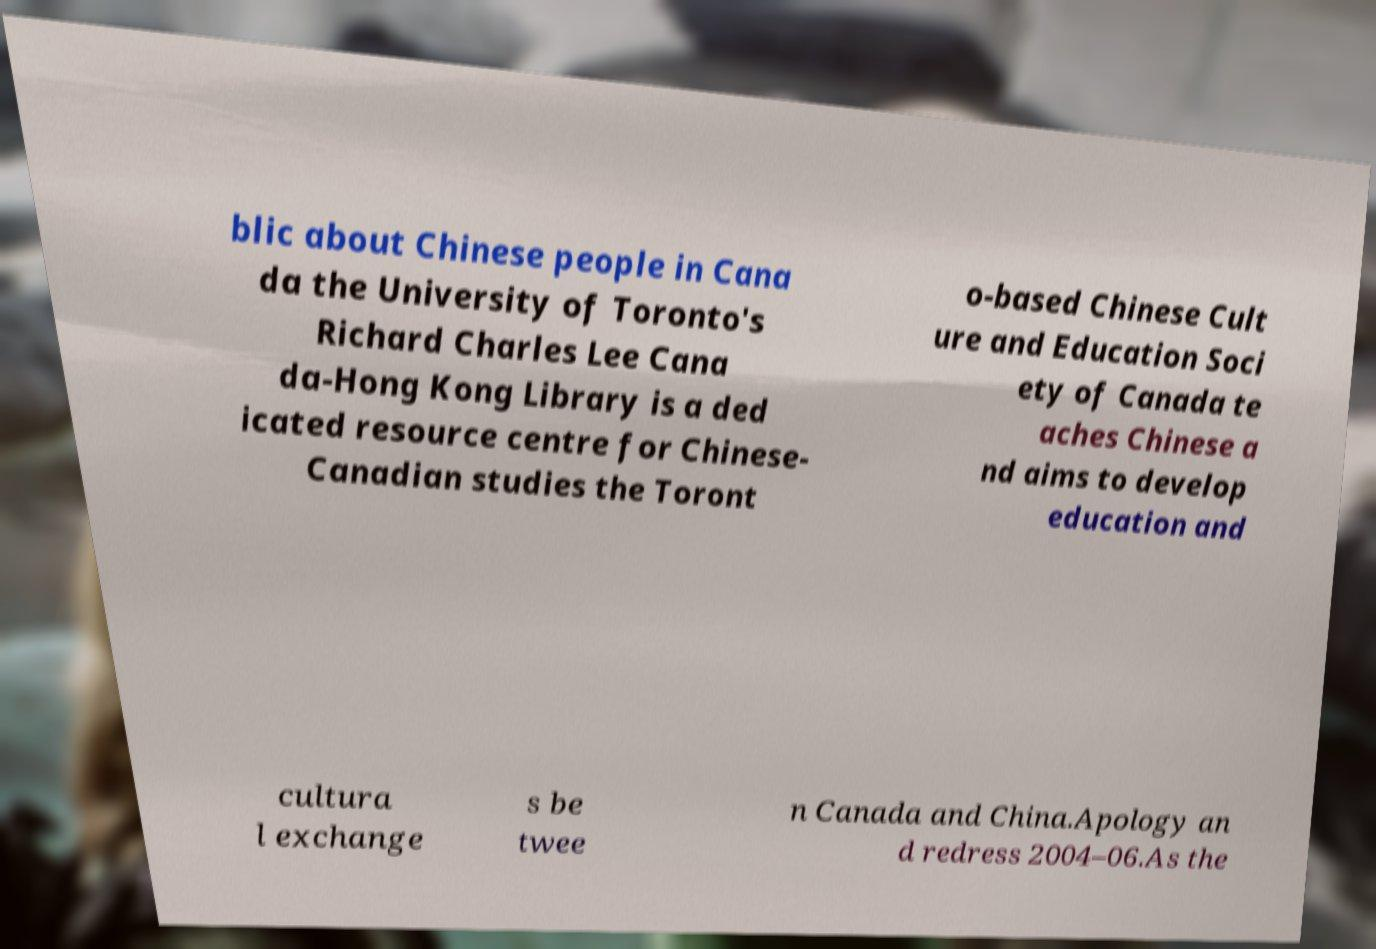Please identify and transcribe the text found in this image. blic about Chinese people in Cana da the University of Toronto's Richard Charles Lee Cana da-Hong Kong Library is a ded icated resource centre for Chinese- Canadian studies the Toront o-based Chinese Cult ure and Education Soci ety of Canada te aches Chinese a nd aims to develop education and cultura l exchange s be twee n Canada and China.Apology an d redress 2004–06.As the 